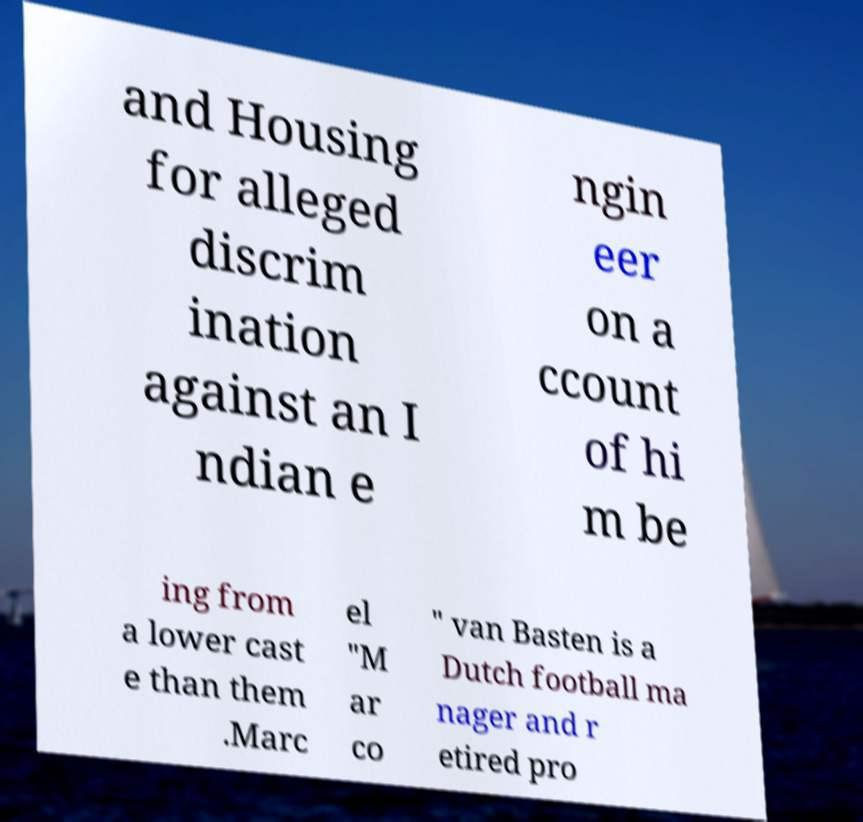What messages or text are displayed in this image? I need them in a readable, typed format. and Housing for alleged discrim ination against an I ndian e ngin eer on a ccount of hi m be ing from a lower cast e than them .Marc el "M ar co " van Basten is a Dutch football ma nager and r etired pro 